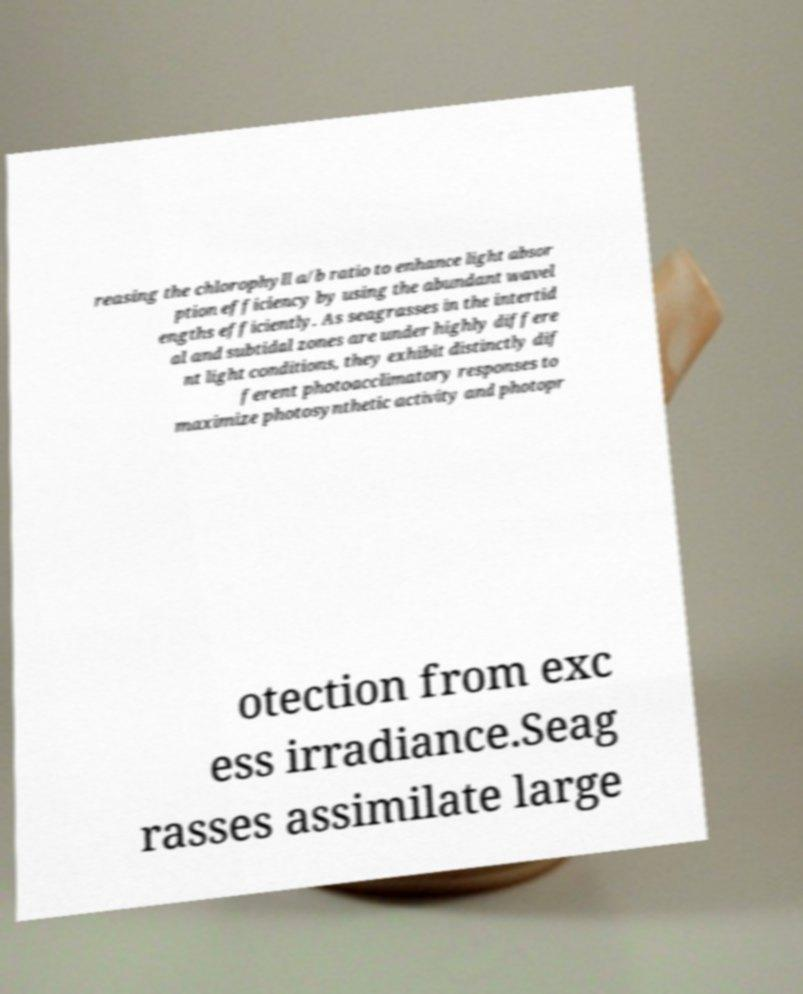Can you read and provide the text displayed in the image?This photo seems to have some interesting text. Can you extract and type it out for me? reasing the chlorophyll a/b ratio to enhance light absor ption efficiency by using the abundant wavel engths efficiently. As seagrasses in the intertid al and subtidal zones are under highly differe nt light conditions, they exhibit distinctly dif ferent photoacclimatory responses to maximize photosynthetic activity and photopr otection from exc ess irradiance.Seag rasses assimilate large 